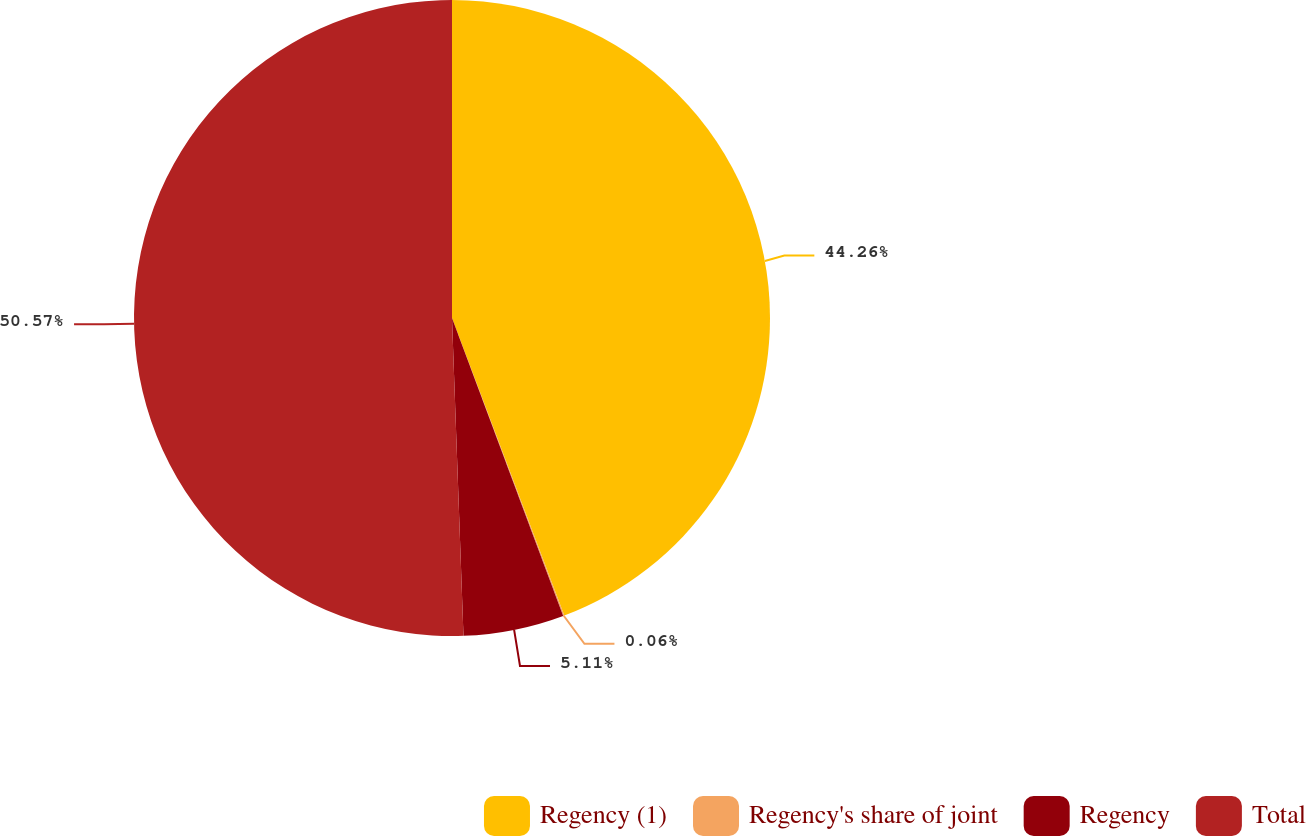Convert chart. <chart><loc_0><loc_0><loc_500><loc_500><pie_chart><fcel>Regency (1)<fcel>Regency's share of joint<fcel>Regency<fcel>Total<nl><fcel>44.26%<fcel>0.06%<fcel>5.11%<fcel>50.58%<nl></chart> 